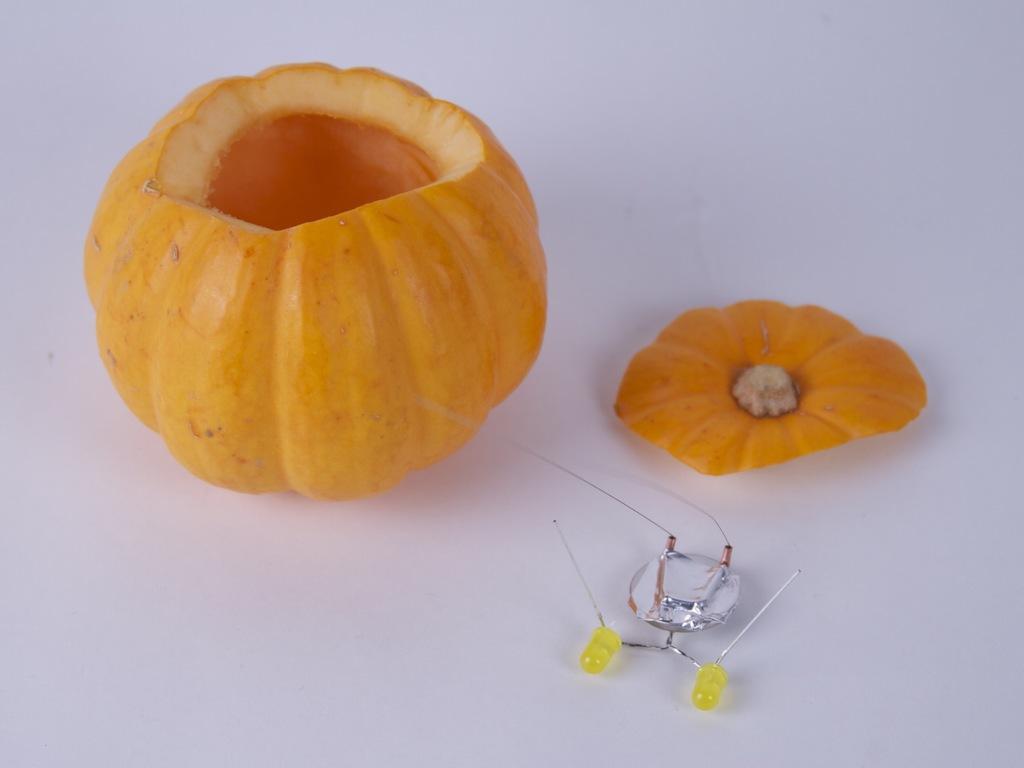In one or two sentences, can you explain what this image depicts? This image consist of a fruit and there is an object which is yellow in colour and these things are kept on the surface which is white in colour. 